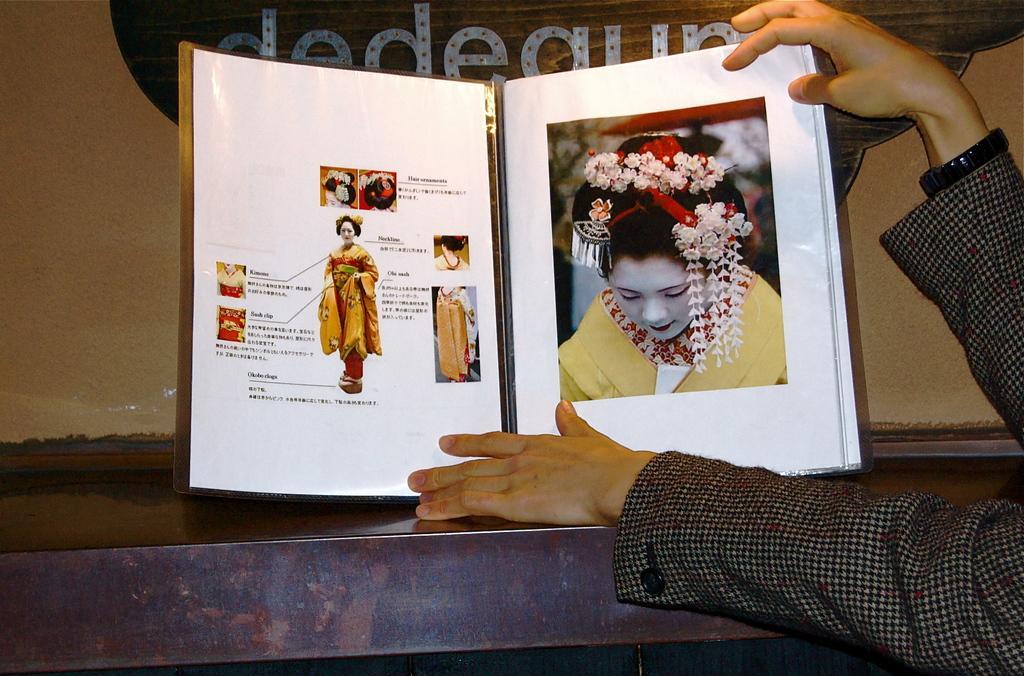In one or two sentences, can you explain what this image depicts? In the image I can see a book on a surface which is holding by a person. In the book I can see photos of women and something written on it. In the background I can see something written on an object which is attached to the wall. 